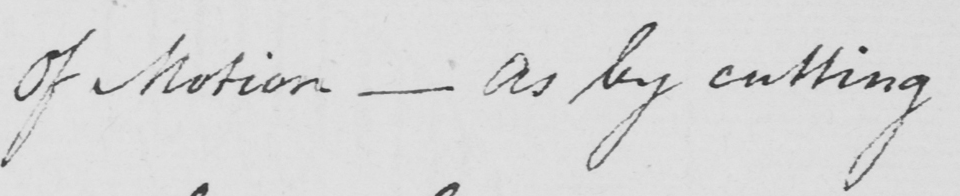What text is written in this handwritten line? Of Motion  _  as by cutting 